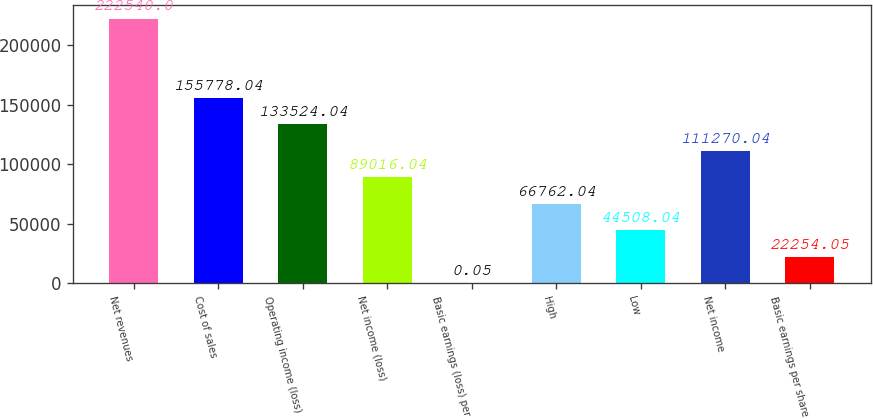Convert chart to OTSL. <chart><loc_0><loc_0><loc_500><loc_500><bar_chart><fcel>Net revenues<fcel>Cost of sales<fcel>Operating income (loss)<fcel>Net income (loss)<fcel>Basic earnings (loss) per<fcel>High<fcel>Low<fcel>Net income<fcel>Basic earnings per share<nl><fcel>222540<fcel>155778<fcel>133524<fcel>89016<fcel>0.05<fcel>66762<fcel>44508<fcel>111270<fcel>22254<nl></chart> 